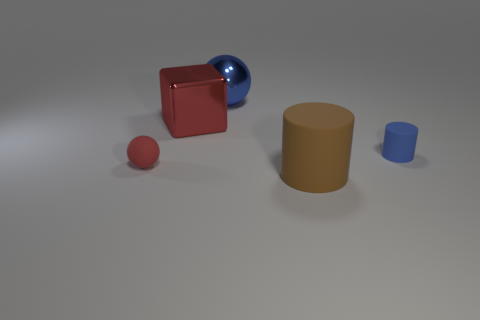The thing that is the same color as the large metal block is what size?
Your answer should be compact. Small. Is the size of the rubber cylinder that is behind the brown cylinder the same as the sphere on the left side of the big blue object?
Offer a very short reply. Yes. Are there any blocks to the left of the tiny rubber object that is left of the red metallic block?
Ensure brevity in your answer.  No. What number of spheres are on the left side of the large red object?
Your answer should be very brief. 1. What number of other objects are there of the same color as the tiny ball?
Provide a short and direct response. 1. Is the number of red rubber objects to the left of the tiny red sphere less than the number of big blue shiny spheres that are left of the big blue metallic ball?
Ensure brevity in your answer.  No. How many things are either rubber cylinders to the left of the blue rubber cylinder or large blue shiny objects?
Your answer should be compact. 2. Is the size of the shiny sphere the same as the matte thing that is in front of the small red sphere?
Offer a very short reply. Yes. The other object that is the same shape as the tiny blue rubber thing is what size?
Ensure brevity in your answer.  Large. How many big rubber cylinders are on the left side of the sphere on the right side of the tiny rubber object in front of the small blue matte thing?
Ensure brevity in your answer.  0. 